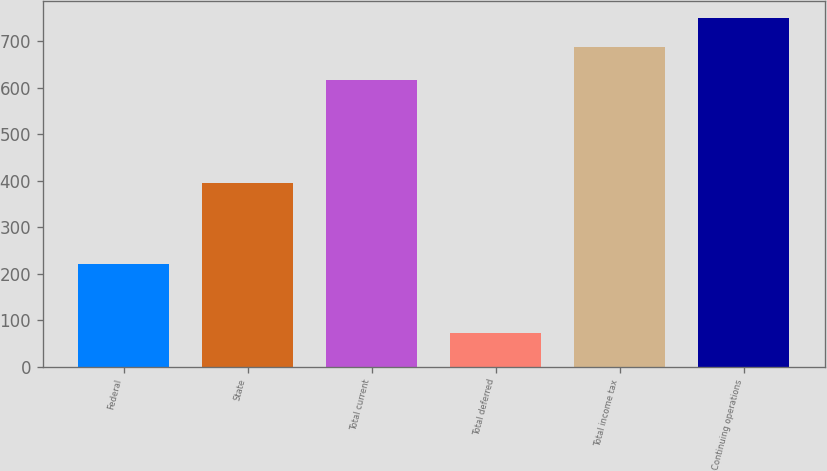<chart> <loc_0><loc_0><loc_500><loc_500><bar_chart><fcel>Federal<fcel>State<fcel>Total current<fcel>Total deferred<fcel>Total income tax<fcel>Continuing operations<nl><fcel>220<fcel>396<fcel>616<fcel>72<fcel>688<fcel>749.6<nl></chart> 